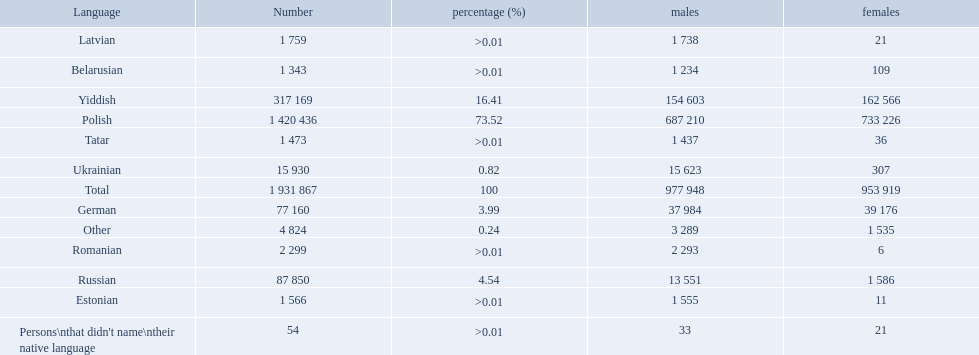How many languages are there? Polish, Yiddish, Russian, German, Ukrainian, Romanian, Latvian, Estonian, Tatar, Belarusian. Which language do more people speak? Polish. What named native languages spoken in the warsaw governorate have more males then females? Russian, Ukrainian, Romanian, Latvian, Estonian, Tatar, Belarusian. Which of those have less then 500 males listed? Romanian, Latvian, Estonian, Tatar, Belarusian. Of the remaining languages which of them have less then 20 females? Romanian, Estonian. Which of these has the highest total number listed? Romanian. Which languages are spoken by more than 50,000 people? Polish, Yiddish, Russian, German. Of these languages, which ones are spoken by less than 15% of the population? Russian, German. Of the remaining two, which one is spoken by 37,984 males? German. 